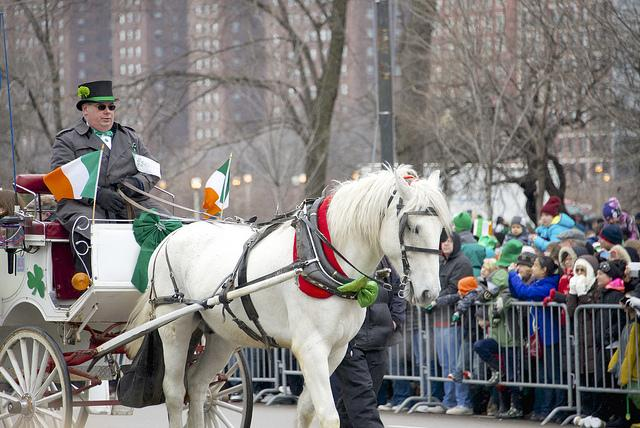What country's flag is on the white carriage?

Choices:
A) italy
B) ireland
C) germany
D) russia ireland 